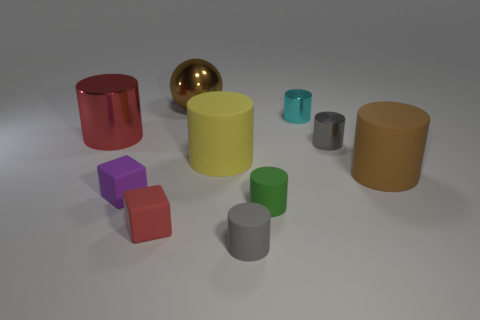Subtract all gray spheres. How many gray cylinders are left? 2 Subtract all small green cylinders. How many cylinders are left? 6 Subtract 5 cylinders. How many cylinders are left? 2 Subtract all brown cylinders. How many cylinders are left? 6 Subtract all cylinders. How many objects are left? 3 Subtract all gray cylinders. Subtract all brown balls. How many cylinders are left? 5 Add 1 tiny green objects. How many tiny green objects exist? 2 Subtract 0 yellow cubes. How many objects are left? 10 Subtract all matte cylinders. Subtract all tiny gray metal cylinders. How many objects are left? 5 Add 4 purple blocks. How many purple blocks are left? 5 